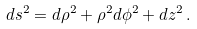<formula> <loc_0><loc_0><loc_500><loc_500>d s ^ { 2 } = d \rho ^ { 2 } + \rho ^ { 2 } d \phi ^ { 2 } + d z ^ { 2 } \, .</formula> 